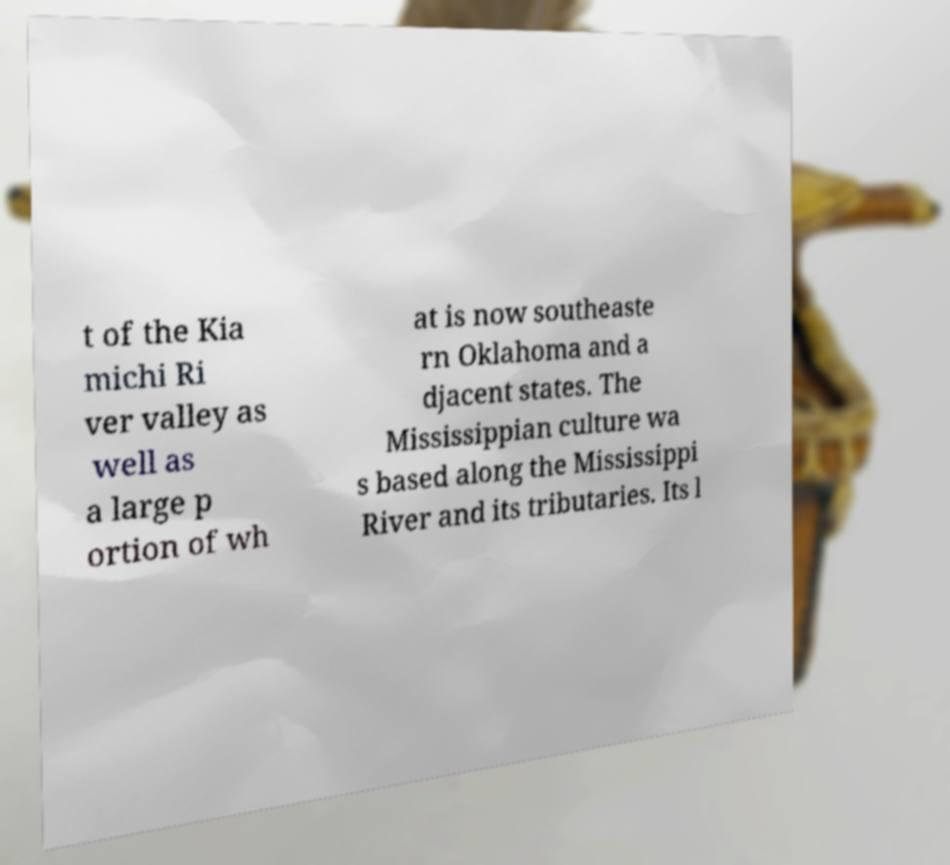Could you extract and type out the text from this image? t of the Kia michi Ri ver valley as well as a large p ortion of wh at is now southeaste rn Oklahoma and a djacent states. The Mississippian culture wa s based along the Mississippi River and its tributaries. Its l 